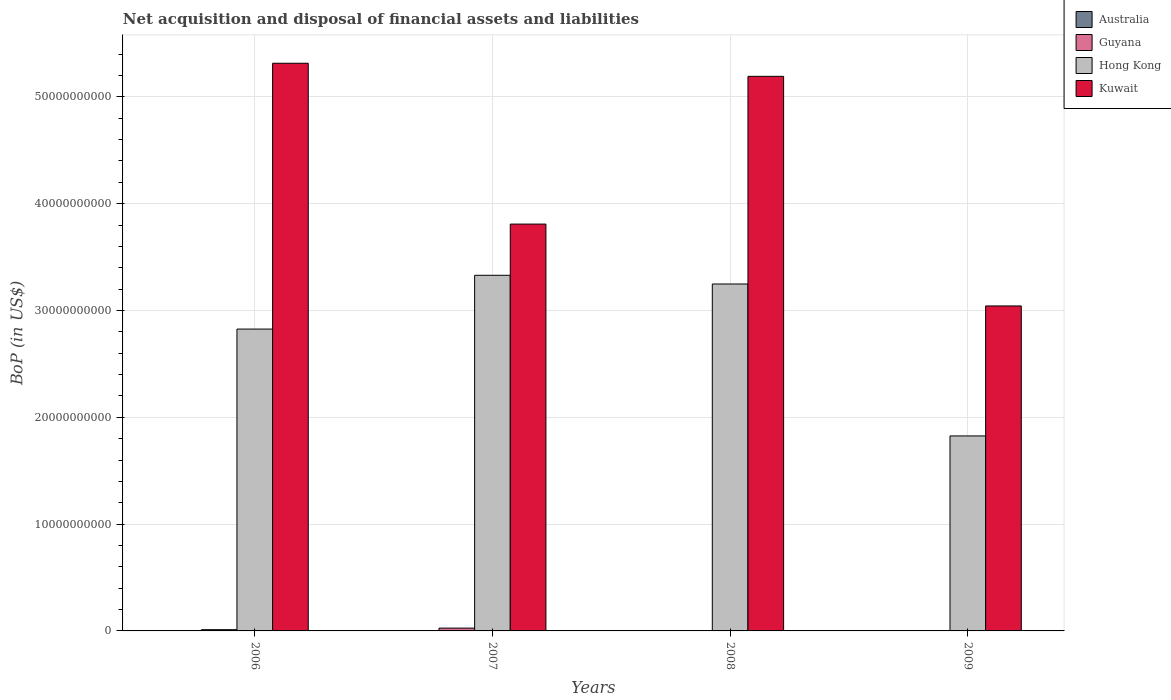How many different coloured bars are there?
Your answer should be compact. 3. How many groups of bars are there?
Your response must be concise. 4. Are the number of bars per tick equal to the number of legend labels?
Offer a very short reply. No. How many bars are there on the 1st tick from the right?
Provide a short and direct response. 2. Across all years, what is the maximum Balance of Payments in Guyana?
Provide a short and direct response. 2.62e+08. In which year was the Balance of Payments in Hong Kong maximum?
Provide a succinct answer. 2007. What is the total Balance of Payments in Guyana in the graph?
Your answer should be very brief. 3.79e+08. What is the difference between the Balance of Payments in Guyana in 2006 and that in 2007?
Your answer should be very brief. -1.46e+08. What is the difference between the Balance of Payments in Kuwait in 2007 and the Balance of Payments in Hong Kong in 2006?
Your response must be concise. 9.83e+09. What is the average Balance of Payments in Australia per year?
Offer a terse response. 0. What is the ratio of the Balance of Payments in Kuwait in 2006 to that in 2008?
Offer a very short reply. 1.02. Is the Balance of Payments in Hong Kong in 2007 less than that in 2009?
Ensure brevity in your answer.  No. What is the difference between the highest and the second highest Balance of Payments in Hong Kong?
Offer a terse response. 8.15e+08. What is the difference between the highest and the lowest Balance of Payments in Kuwait?
Provide a succinct answer. 2.27e+1. In how many years, is the Balance of Payments in Kuwait greater than the average Balance of Payments in Kuwait taken over all years?
Offer a very short reply. 2. Is it the case that in every year, the sum of the Balance of Payments in Kuwait and Balance of Payments in Guyana is greater than the Balance of Payments in Australia?
Offer a terse response. Yes. What is the difference between two consecutive major ticks on the Y-axis?
Your answer should be compact. 1.00e+1. Are the values on the major ticks of Y-axis written in scientific E-notation?
Provide a short and direct response. No. Does the graph contain any zero values?
Keep it short and to the point. Yes. Does the graph contain grids?
Provide a short and direct response. Yes. How are the legend labels stacked?
Give a very brief answer. Vertical. What is the title of the graph?
Your response must be concise. Net acquisition and disposal of financial assets and liabilities. Does "Channel Islands" appear as one of the legend labels in the graph?
Your answer should be compact. No. What is the label or title of the X-axis?
Provide a short and direct response. Years. What is the label or title of the Y-axis?
Provide a short and direct response. BoP (in US$). What is the BoP (in US$) in Australia in 2006?
Provide a short and direct response. 0. What is the BoP (in US$) in Guyana in 2006?
Your answer should be compact. 1.16e+08. What is the BoP (in US$) in Hong Kong in 2006?
Provide a succinct answer. 2.83e+1. What is the BoP (in US$) of Kuwait in 2006?
Give a very brief answer. 5.31e+1. What is the BoP (in US$) of Guyana in 2007?
Keep it short and to the point. 2.62e+08. What is the BoP (in US$) in Hong Kong in 2007?
Keep it short and to the point. 3.33e+1. What is the BoP (in US$) in Kuwait in 2007?
Keep it short and to the point. 3.81e+1. What is the BoP (in US$) of Australia in 2008?
Your answer should be compact. 0. What is the BoP (in US$) in Guyana in 2008?
Provide a short and direct response. 0. What is the BoP (in US$) in Hong Kong in 2008?
Your answer should be compact. 3.25e+1. What is the BoP (in US$) of Kuwait in 2008?
Provide a short and direct response. 5.19e+1. What is the BoP (in US$) of Hong Kong in 2009?
Ensure brevity in your answer.  1.83e+1. What is the BoP (in US$) of Kuwait in 2009?
Give a very brief answer. 3.04e+1. Across all years, what is the maximum BoP (in US$) of Guyana?
Offer a very short reply. 2.62e+08. Across all years, what is the maximum BoP (in US$) in Hong Kong?
Make the answer very short. 3.33e+1. Across all years, what is the maximum BoP (in US$) in Kuwait?
Your response must be concise. 5.31e+1. Across all years, what is the minimum BoP (in US$) of Hong Kong?
Provide a succinct answer. 1.83e+1. Across all years, what is the minimum BoP (in US$) of Kuwait?
Make the answer very short. 3.04e+1. What is the total BoP (in US$) in Australia in the graph?
Give a very brief answer. 0. What is the total BoP (in US$) of Guyana in the graph?
Provide a short and direct response. 3.79e+08. What is the total BoP (in US$) of Hong Kong in the graph?
Your answer should be very brief. 1.12e+11. What is the total BoP (in US$) of Kuwait in the graph?
Keep it short and to the point. 1.74e+11. What is the difference between the BoP (in US$) of Guyana in 2006 and that in 2007?
Your answer should be compact. -1.46e+08. What is the difference between the BoP (in US$) in Hong Kong in 2006 and that in 2007?
Provide a short and direct response. -5.04e+09. What is the difference between the BoP (in US$) in Kuwait in 2006 and that in 2007?
Provide a short and direct response. 1.51e+1. What is the difference between the BoP (in US$) in Hong Kong in 2006 and that in 2008?
Provide a succinct answer. -4.22e+09. What is the difference between the BoP (in US$) of Kuwait in 2006 and that in 2008?
Provide a succinct answer. 1.22e+09. What is the difference between the BoP (in US$) of Hong Kong in 2006 and that in 2009?
Offer a terse response. 1.00e+1. What is the difference between the BoP (in US$) of Kuwait in 2006 and that in 2009?
Your answer should be compact. 2.27e+1. What is the difference between the BoP (in US$) in Hong Kong in 2007 and that in 2008?
Provide a short and direct response. 8.15e+08. What is the difference between the BoP (in US$) of Kuwait in 2007 and that in 2008?
Ensure brevity in your answer.  -1.38e+1. What is the difference between the BoP (in US$) of Hong Kong in 2007 and that in 2009?
Ensure brevity in your answer.  1.50e+1. What is the difference between the BoP (in US$) of Kuwait in 2007 and that in 2009?
Ensure brevity in your answer.  7.66e+09. What is the difference between the BoP (in US$) in Hong Kong in 2008 and that in 2009?
Your answer should be compact. 1.42e+1. What is the difference between the BoP (in US$) of Kuwait in 2008 and that in 2009?
Ensure brevity in your answer.  2.15e+1. What is the difference between the BoP (in US$) in Guyana in 2006 and the BoP (in US$) in Hong Kong in 2007?
Provide a succinct answer. -3.32e+1. What is the difference between the BoP (in US$) in Guyana in 2006 and the BoP (in US$) in Kuwait in 2007?
Your response must be concise. -3.80e+1. What is the difference between the BoP (in US$) of Hong Kong in 2006 and the BoP (in US$) of Kuwait in 2007?
Provide a succinct answer. -9.83e+09. What is the difference between the BoP (in US$) of Guyana in 2006 and the BoP (in US$) of Hong Kong in 2008?
Provide a short and direct response. -3.24e+1. What is the difference between the BoP (in US$) in Guyana in 2006 and the BoP (in US$) in Kuwait in 2008?
Provide a short and direct response. -5.18e+1. What is the difference between the BoP (in US$) in Hong Kong in 2006 and the BoP (in US$) in Kuwait in 2008?
Offer a very short reply. -2.37e+1. What is the difference between the BoP (in US$) in Guyana in 2006 and the BoP (in US$) in Hong Kong in 2009?
Your answer should be compact. -1.81e+1. What is the difference between the BoP (in US$) in Guyana in 2006 and the BoP (in US$) in Kuwait in 2009?
Your answer should be compact. -3.03e+1. What is the difference between the BoP (in US$) in Hong Kong in 2006 and the BoP (in US$) in Kuwait in 2009?
Your answer should be very brief. -2.16e+09. What is the difference between the BoP (in US$) of Guyana in 2007 and the BoP (in US$) of Hong Kong in 2008?
Offer a very short reply. -3.22e+1. What is the difference between the BoP (in US$) of Guyana in 2007 and the BoP (in US$) of Kuwait in 2008?
Make the answer very short. -5.17e+1. What is the difference between the BoP (in US$) in Hong Kong in 2007 and the BoP (in US$) in Kuwait in 2008?
Offer a terse response. -1.86e+1. What is the difference between the BoP (in US$) in Guyana in 2007 and the BoP (in US$) in Hong Kong in 2009?
Make the answer very short. -1.80e+1. What is the difference between the BoP (in US$) of Guyana in 2007 and the BoP (in US$) of Kuwait in 2009?
Keep it short and to the point. -3.02e+1. What is the difference between the BoP (in US$) of Hong Kong in 2007 and the BoP (in US$) of Kuwait in 2009?
Keep it short and to the point. 2.87e+09. What is the difference between the BoP (in US$) in Hong Kong in 2008 and the BoP (in US$) in Kuwait in 2009?
Keep it short and to the point. 2.06e+09. What is the average BoP (in US$) in Guyana per year?
Ensure brevity in your answer.  9.46e+07. What is the average BoP (in US$) of Hong Kong per year?
Provide a succinct answer. 2.81e+1. What is the average BoP (in US$) in Kuwait per year?
Your response must be concise. 4.34e+1. In the year 2006, what is the difference between the BoP (in US$) of Guyana and BoP (in US$) of Hong Kong?
Your response must be concise. -2.81e+1. In the year 2006, what is the difference between the BoP (in US$) of Guyana and BoP (in US$) of Kuwait?
Your answer should be very brief. -5.30e+1. In the year 2006, what is the difference between the BoP (in US$) of Hong Kong and BoP (in US$) of Kuwait?
Your answer should be compact. -2.49e+1. In the year 2007, what is the difference between the BoP (in US$) of Guyana and BoP (in US$) of Hong Kong?
Ensure brevity in your answer.  -3.30e+1. In the year 2007, what is the difference between the BoP (in US$) in Guyana and BoP (in US$) in Kuwait?
Provide a short and direct response. -3.78e+1. In the year 2007, what is the difference between the BoP (in US$) in Hong Kong and BoP (in US$) in Kuwait?
Ensure brevity in your answer.  -4.79e+09. In the year 2008, what is the difference between the BoP (in US$) of Hong Kong and BoP (in US$) of Kuwait?
Offer a very short reply. -1.94e+1. In the year 2009, what is the difference between the BoP (in US$) of Hong Kong and BoP (in US$) of Kuwait?
Ensure brevity in your answer.  -1.22e+1. What is the ratio of the BoP (in US$) in Guyana in 2006 to that in 2007?
Your response must be concise. 0.44. What is the ratio of the BoP (in US$) in Hong Kong in 2006 to that in 2007?
Provide a short and direct response. 0.85. What is the ratio of the BoP (in US$) of Kuwait in 2006 to that in 2007?
Provide a succinct answer. 1.4. What is the ratio of the BoP (in US$) in Hong Kong in 2006 to that in 2008?
Make the answer very short. 0.87. What is the ratio of the BoP (in US$) of Kuwait in 2006 to that in 2008?
Provide a short and direct response. 1.02. What is the ratio of the BoP (in US$) of Hong Kong in 2006 to that in 2009?
Provide a short and direct response. 1.55. What is the ratio of the BoP (in US$) in Kuwait in 2006 to that in 2009?
Offer a very short reply. 1.75. What is the ratio of the BoP (in US$) of Hong Kong in 2007 to that in 2008?
Provide a short and direct response. 1.03. What is the ratio of the BoP (in US$) in Kuwait in 2007 to that in 2008?
Your answer should be very brief. 0.73. What is the ratio of the BoP (in US$) in Hong Kong in 2007 to that in 2009?
Your response must be concise. 1.82. What is the ratio of the BoP (in US$) in Kuwait in 2007 to that in 2009?
Give a very brief answer. 1.25. What is the ratio of the BoP (in US$) in Hong Kong in 2008 to that in 2009?
Your answer should be very brief. 1.78. What is the ratio of the BoP (in US$) in Kuwait in 2008 to that in 2009?
Provide a succinct answer. 1.71. What is the difference between the highest and the second highest BoP (in US$) in Hong Kong?
Keep it short and to the point. 8.15e+08. What is the difference between the highest and the second highest BoP (in US$) in Kuwait?
Offer a terse response. 1.22e+09. What is the difference between the highest and the lowest BoP (in US$) of Guyana?
Make the answer very short. 2.62e+08. What is the difference between the highest and the lowest BoP (in US$) of Hong Kong?
Offer a terse response. 1.50e+1. What is the difference between the highest and the lowest BoP (in US$) of Kuwait?
Ensure brevity in your answer.  2.27e+1. 